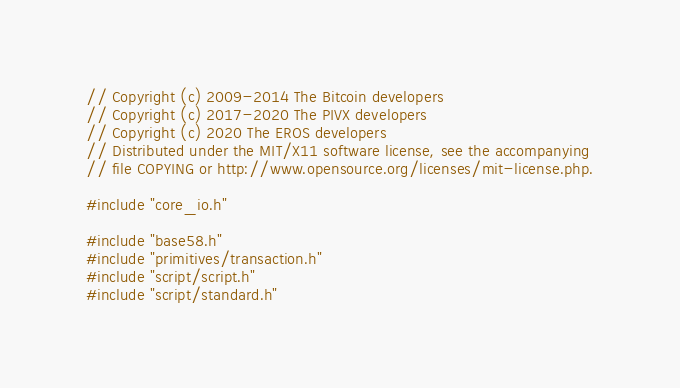Convert code to text. <code><loc_0><loc_0><loc_500><loc_500><_C++_>// Copyright (c) 2009-2014 The Bitcoin developers
// Copyright (c) 2017-2020 The PIVX developers
// Copyright (c) 2020 The EROS developers
// Distributed under the MIT/X11 software license, see the accompanying
// file COPYING or http://www.opensource.org/licenses/mit-license.php.

#include "core_io.h"

#include "base58.h"
#include "primitives/transaction.h"
#include "script/script.h"
#include "script/standard.h"</code> 